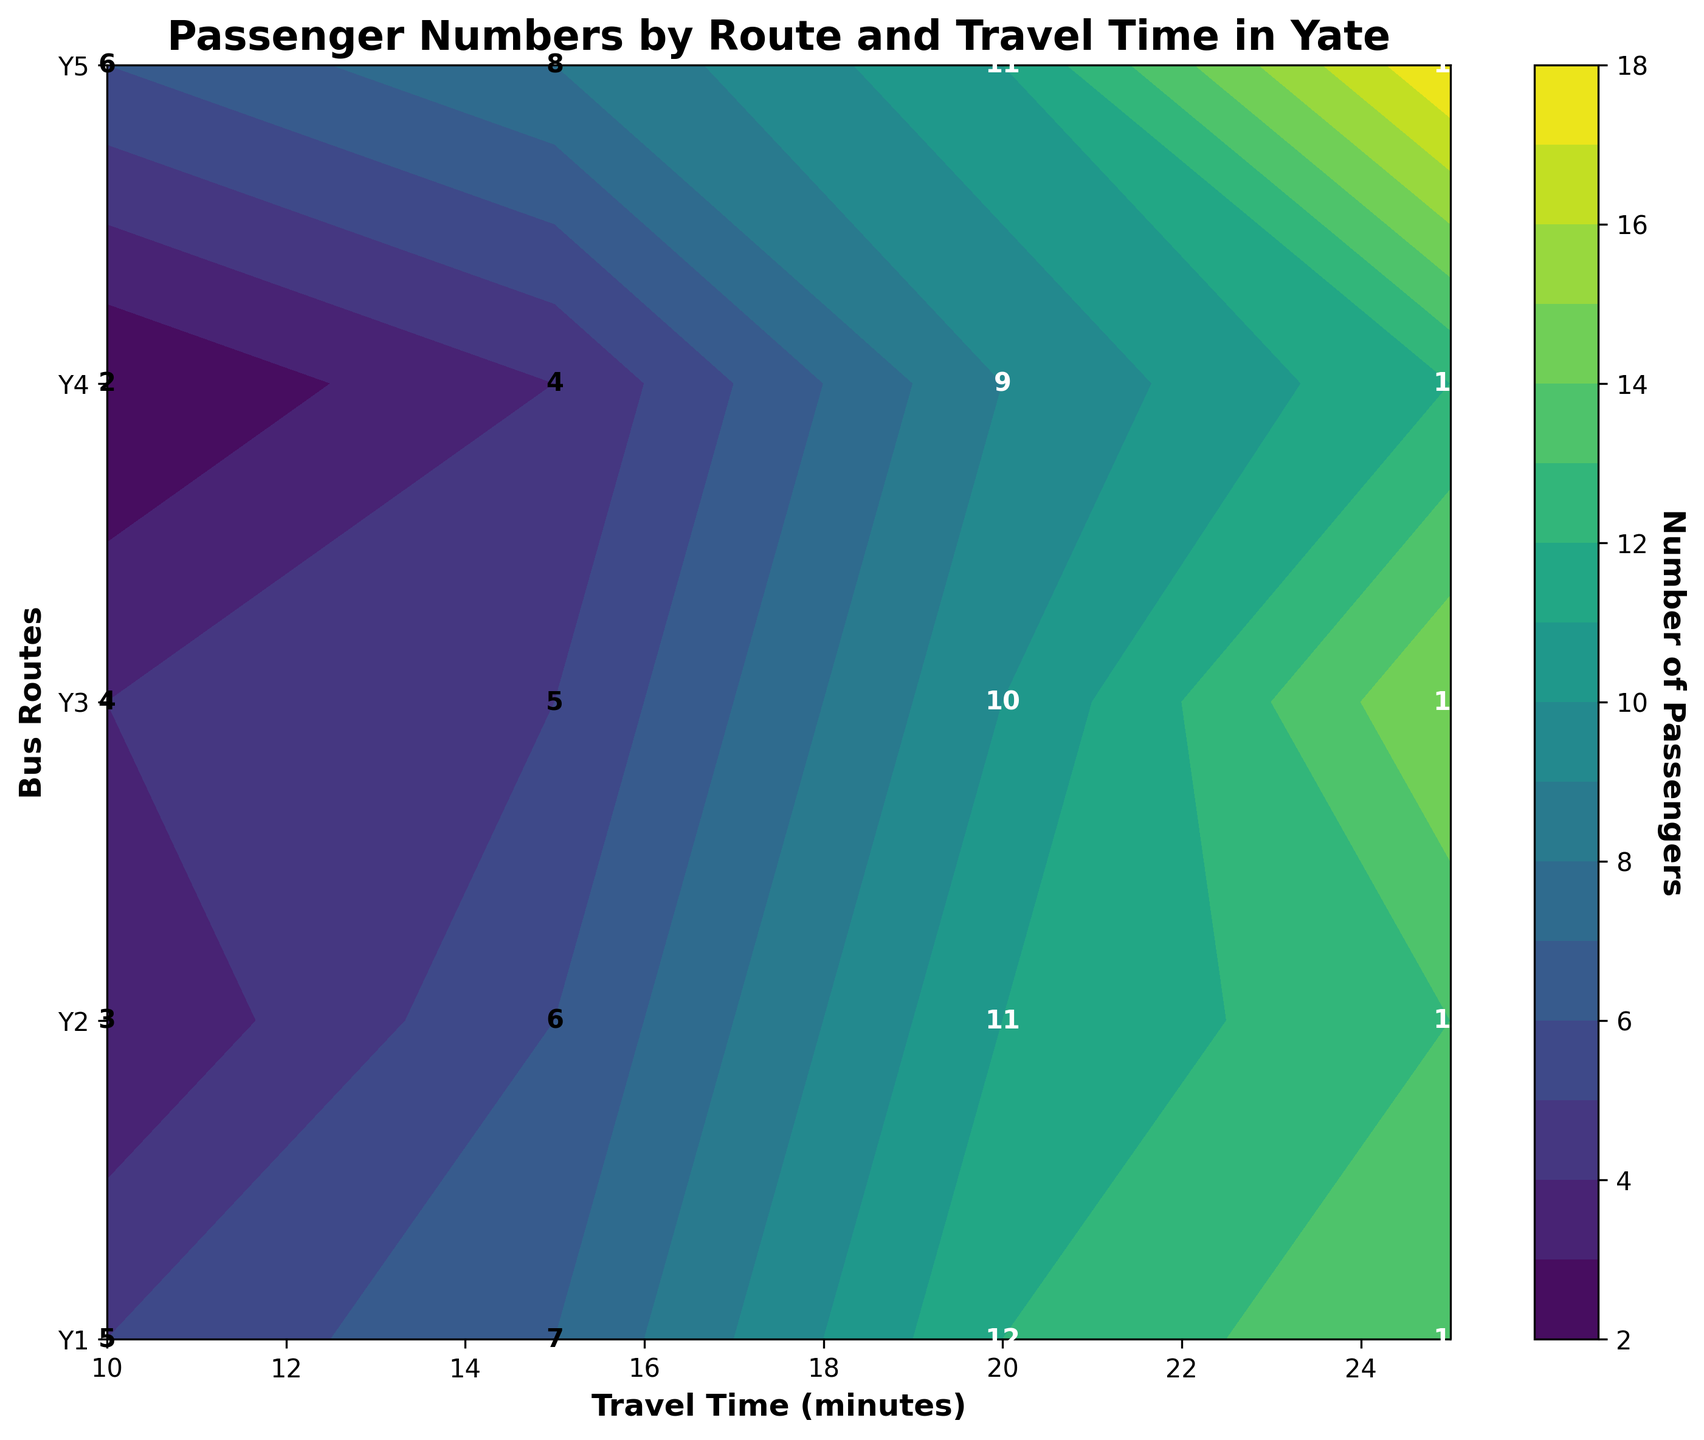What is the title of the chart? The title is written at the top of the chart. It states: "Passenger Numbers by Route and Travel Time in Yate".
Answer: Passenger Numbers by Route and Travel Time in Yate Which bus route has the highest number of passengers for a 25-minute travel time? Look at the contour plot corresponding to 25 minutes on the x-axis and find the cell with the highest number. Route Y5 has the highest count with 18 passengers.
Answer: Y5 At what travel time do Route Y3 passengers number 10? Find the route Y3 on the y-axis and follow horizontally to find the cell that has 10 passengers. This corresponds to a travel time of 20 minutes.
Answer: 20 minutes How many passengers are there on Route Y1 when the travel time is 10 minutes? Locate Route Y1 on the y-axis, then find the cell where it intersects with 10 minutes on the x-axis. The number in that cell is 5 passengers.
Answer: 5 Which route has the least number of passengers for any travel time? Identify the route with the smallest number in any of the cells corresponding to it. Route Y4 has the least with 2 passengers at 10 minutes.
Answer: Y4 What is the average number of passengers for Route Y2 across all travel times? Sum the passengers for Route Y2 (3+6+11+13) and divide by the number of travel times (4). The total is 33, and the average is 33/4.
Answer: 8.25 Which route shows the most consistent number of passengers regardless of travel time? Compare the variability of passengers across all travel times for each route. Route Y4 has relatively consistent passenger numbers from 2 to 12.
Answer: Y4 Are there more passengers on average on shorter travel times (10 to 15 minutes) or longer travel times (20 to 25 minutes)? Calculate the average passengers for shorter times (mean of values at 10 and 15 minutes) and longer times (mean of values at 20 and 25 minutes) then compare. Average for shorter times (4+6+4+2+6)/5 = 4.4, and for longer times (10+15+11+12+18)/5 = 13.2.
Answer: Longer travel times Is there any route where the number of passengers increases with travel time? Examine each route to see if passenger numbers increase as travel time increases. All routes show an increase in the number of passengers as travel time increases.
Answer: Yes What color represents the highest number of passengers on the contour plot? The highest number of passengers on the contour plot is 18, which is shown in the darkest shade of the color used in the 'viridis' colormap.
Answer: Darkest shade (near purple) 